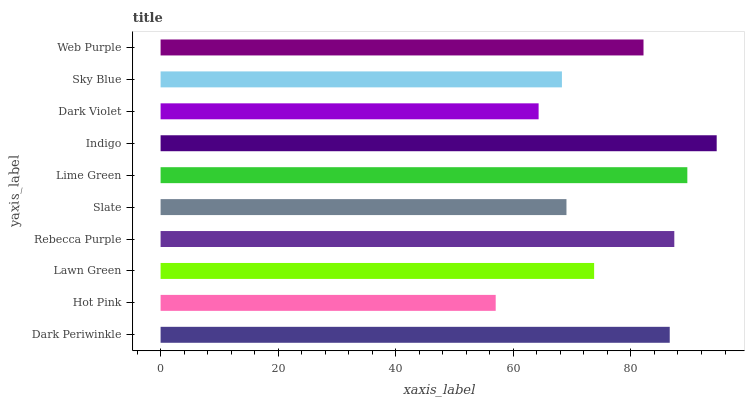Is Hot Pink the minimum?
Answer yes or no. Yes. Is Indigo the maximum?
Answer yes or no. Yes. Is Lawn Green the minimum?
Answer yes or no. No. Is Lawn Green the maximum?
Answer yes or no. No. Is Lawn Green greater than Hot Pink?
Answer yes or no. Yes. Is Hot Pink less than Lawn Green?
Answer yes or no. Yes. Is Hot Pink greater than Lawn Green?
Answer yes or no. No. Is Lawn Green less than Hot Pink?
Answer yes or no. No. Is Web Purple the high median?
Answer yes or no. Yes. Is Lawn Green the low median?
Answer yes or no. Yes. Is Sky Blue the high median?
Answer yes or no. No. Is Dark Violet the low median?
Answer yes or no. No. 